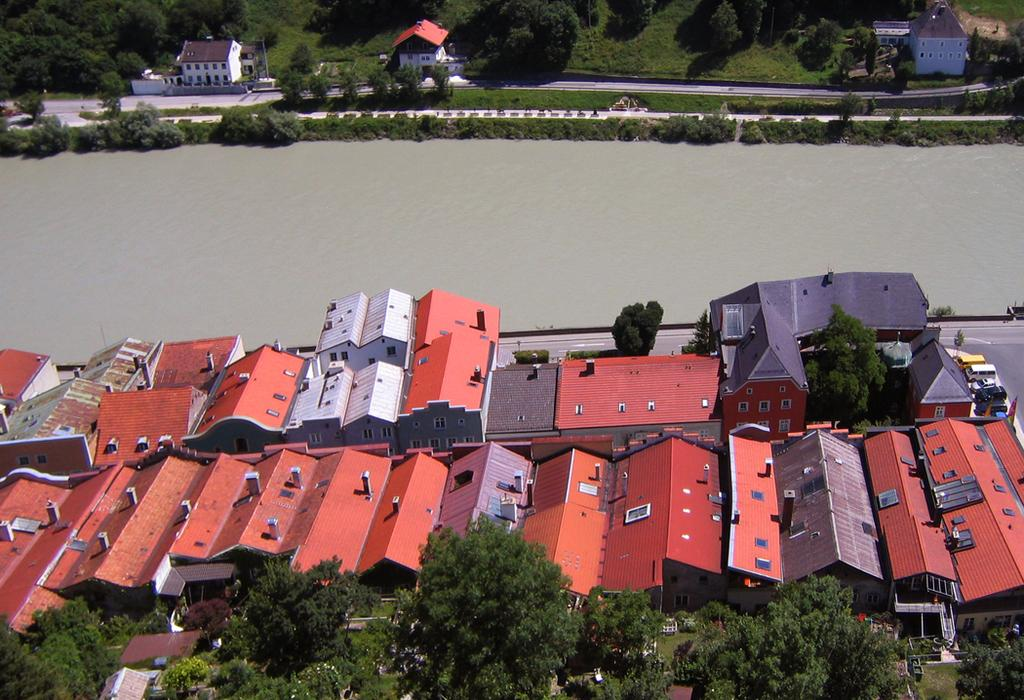What is the primary element visible in the image? There is water in the image. What structures are located near the water? There are buildings on either side of the water. What type of vegetation is present near the water? There are trees on either side of the water. What can be seen in the right corner of the image? There are vehicles in the right corner of the image. What color is the crayon used to draw the skate on the ice in the image? There is no ice, crayon, or skate present in the image. 